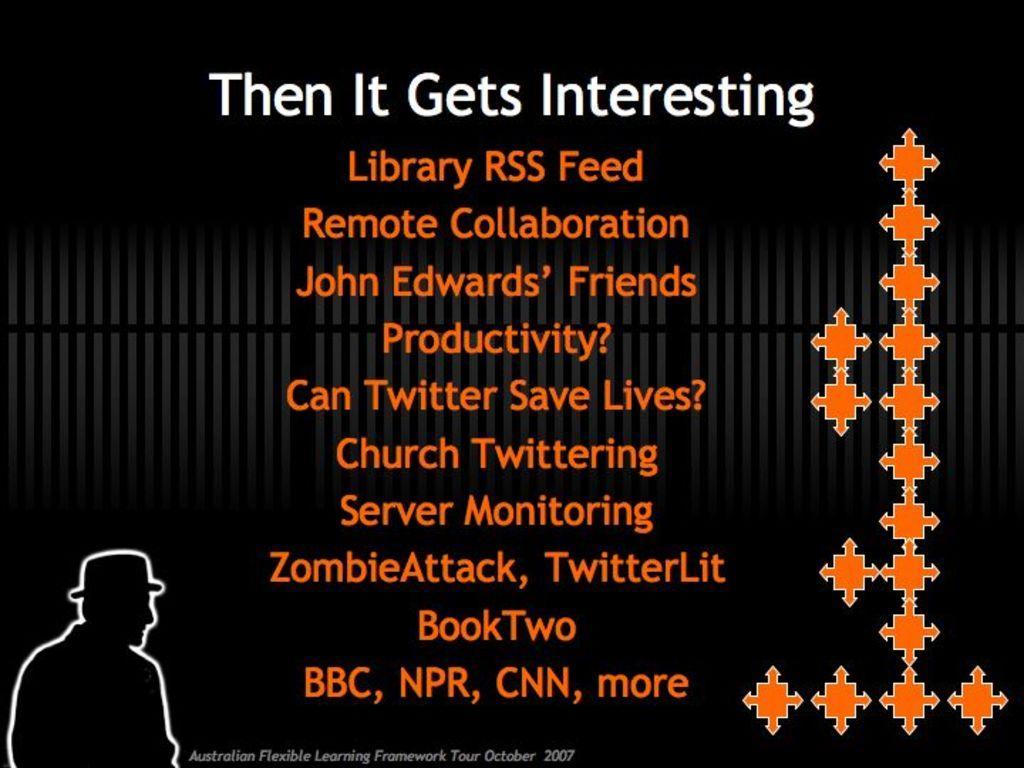How would you summarize this image in a sentence or two? This image consists of a poster. On this poster, I can see some text. The background is in black color. 